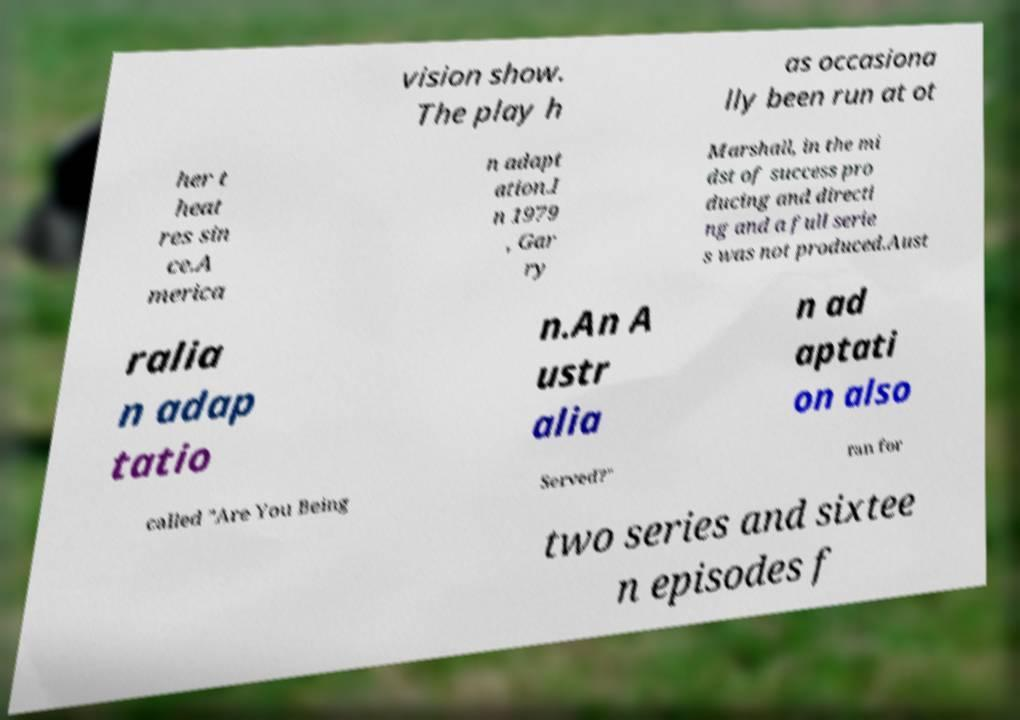Please read and relay the text visible in this image. What does it say? vision show. The play h as occasiona lly been run at ot her t heat res sin ce.A merica n adapt ation.I n 1979 , Gar ry Marshall, in the mi dst of success pro ducing and directi ng and a full serie s was not produced.Aust ralia n adap tatio n.An A ustr alia n ad aptati on also called "Are You Being Served?" ran for two series and sixtee n episodes f 